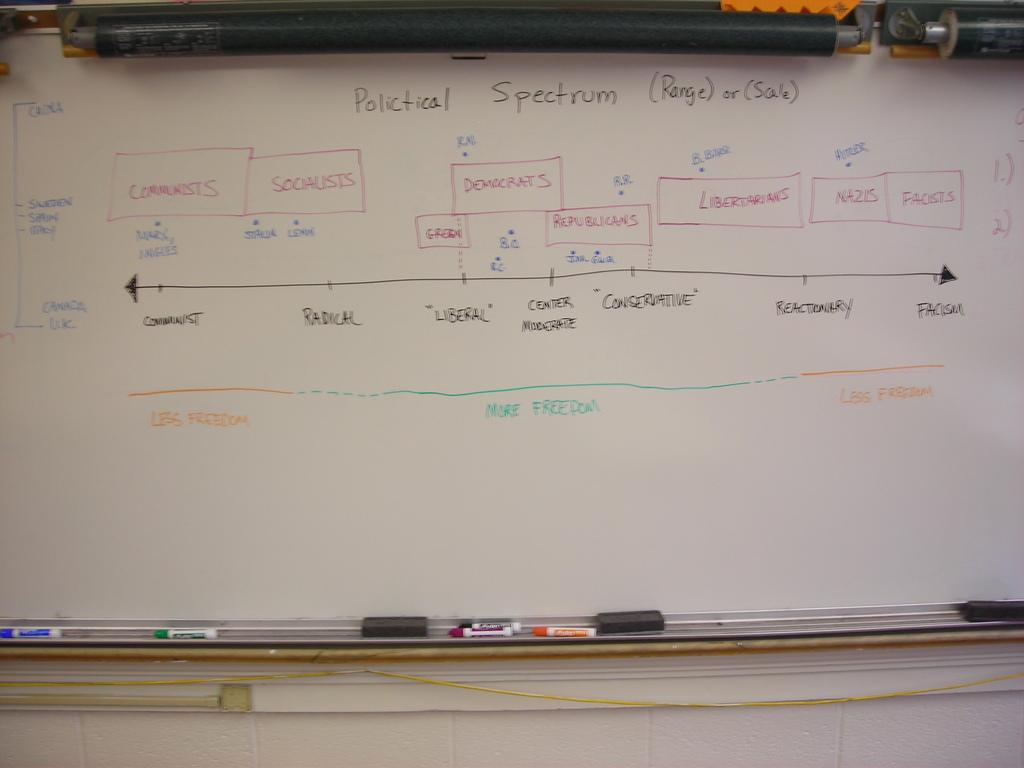<image>
Offer a succinct explanation of the picture presented. White board show a chart for polictical spectrum 